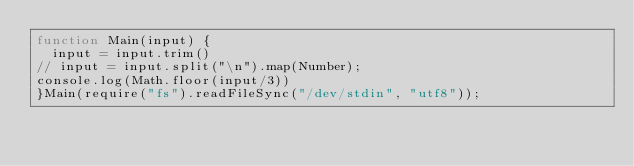<code> <loc_0><loc_0><loc_500><loc_500><_JavaScript_>function Main(input) {
  input = input.trim()
// input = input.split("\n").map(Number);
console.log(Math.floor(input/3))
}Main(require("fs").readFileSync("/dev/stdin", "utf8"));</code> 